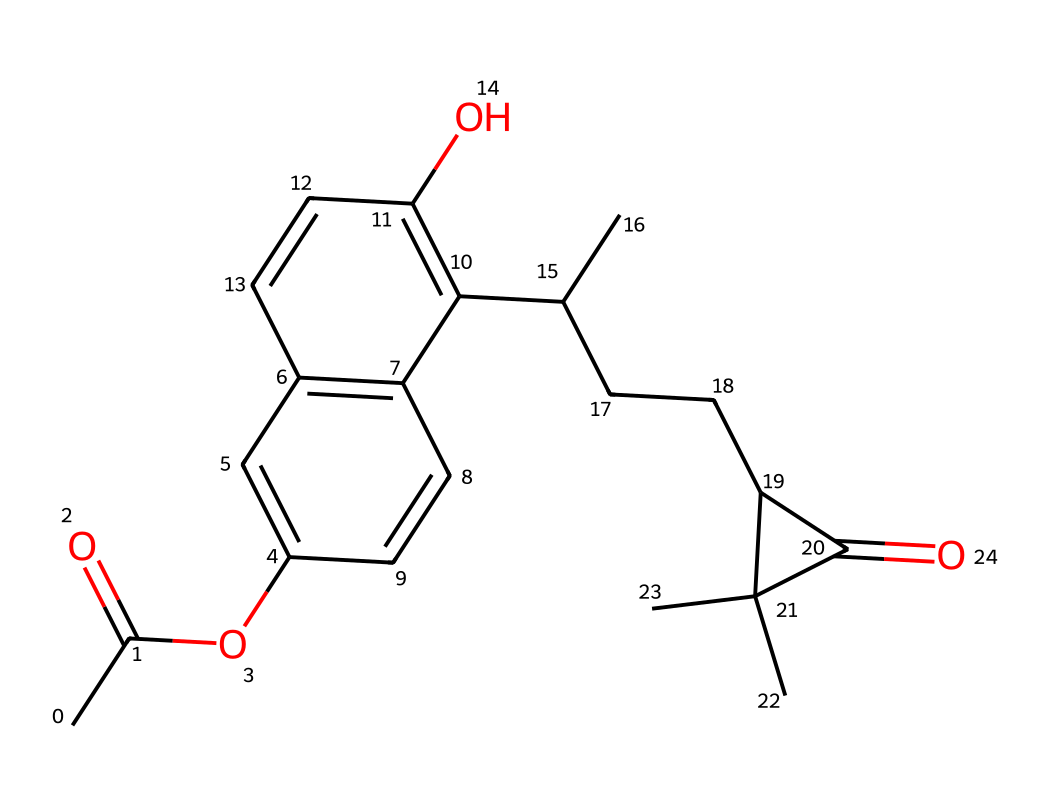What is the molecular formula of this compound? The molecular formula can be derived by counting the number of each type of atom present in the SMILES representation. Analyzing the structure, we find there are 15 carbon atoms, 20 hydrogen atoms, and 2 oxygen atoms. Therefore, the molecular formula is C15H20O2.
Answer: C15H20O2 How many rings are present in the chemical structure? By observing the structure derived from the SMILES representation, I can identify two distinct ring structures. The connections between atoms that form loops indicate the presence of two rings in the molecule.
Answer: 2 Is this compound more likely to be hydrophilic or hydrophobic? The presence of hydroxyl (-OH) groups and other polar bonds suggests that this compound interacts well with water. This leads to the conclusion that the compound is hydrophilic; it can form hydrogen bonds.
Answer: hydrophilic What type of chemical compound is represented here? The structure displayed indicates that this compound is a type of terpene, specifically a cannabinoid, given the presence of cyclohexane rings and its typical functional groups. Terpenes are known for their occurrence in plants, particularly in cannabis.
Answer: cannabinoid What functional groups are present in the chemical structure? Examining the SMILES notation reveals two significant functional groups: an ester (-COO-) and a hydroxyl group (-OH). These functional groups play a role in the compound's biological activity and pharmacological properties.
Answer: ester, hydroxyl What is the significance of the oxygen atoms in this molecule? The oxygen atoms in the structure can influence the chemical's reactivity and polarity. They are part of the functional groups that contribute to the pharmacological effects of cannabinoids, which are critical in determining how the compound interacts with biological systems.
Answer: reactivity, polarity 